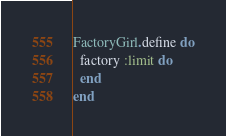Convert code to text. <code><loc_0><loc_0><loc_500><loc_500><_Ruby_>FactoryGirl.define do
  factory :limit do
  end
end
</code> 